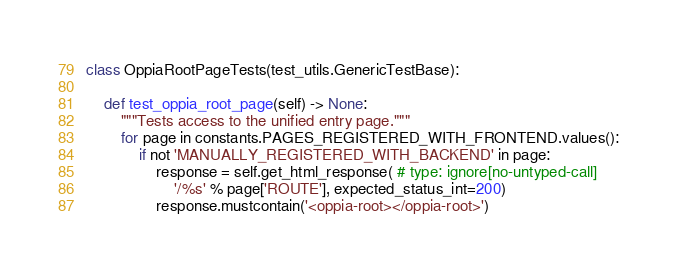<code> <loc_0><loc_0><loc_500><loc_500><_Python_>

class OppiaRootPageTests(test_utils.GenericTestBase):

    def test_oppia_root_page(self) -> None:
        """Tests access to the unified entry page."""
        for page in constants.PAGES_REGISTERED_WITH_FRONTEND.values():
            if not 'MANUALLY_REGISTERED_WITH_BACKEND' in page:
                response = self.get_html_response( # type: ignore[no-untyped-call]
                    '/%s' % page['ROUTE'], expected_status_int=200)
                response.mustcontain('<oppia-root></oppia-root>')
</code> 